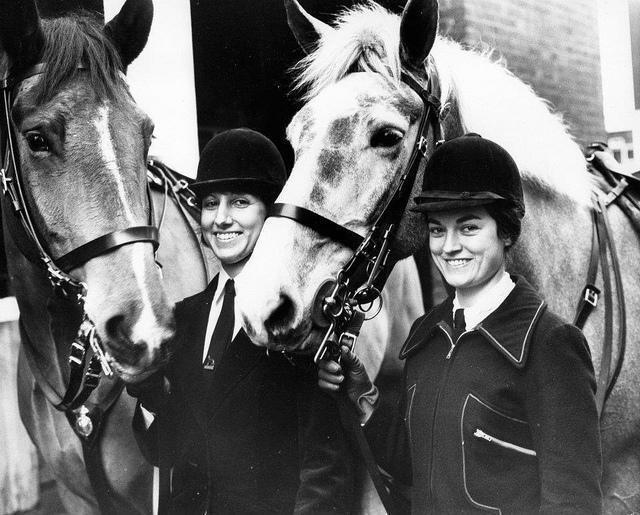How many women?
Give a very brief answer. 2. How many people are visible?
Give a very brief answer. 2. How many horses are visible?
Give a very brief answer. 2. How many chairs are shown around the table?
Give a very brief answer. 0. 